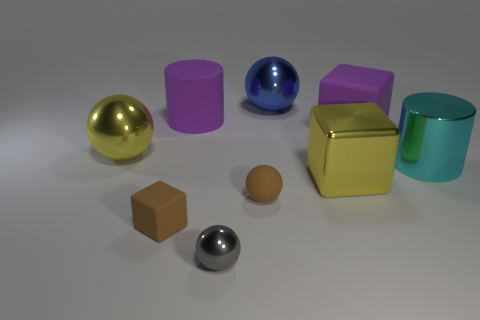Is the number of yellow objects to the right of the yellow metallic sphere greater than the number of cyan metallic cylinders?
Offer a terse response. No. Is the ball on the left side of the small metallic ball made of the same material as the blue object?
Offer a terse response. Yes. There is a cube in front of the tiny brown object right of the brown object that is on the left side of the small gray metallic thing; what is its size?
Make the answer very short. Small. There is a cylinder that is the same material as the blue sphere; what is its size?
Keep it short and to the point. Large. What is the color of the object that is on the right side of the large yellow block and to the left of the cyan thing?
Make the answer very short. Purple. There is a yellow object right of the large yellow metallic sphere; is its shape the same as the brown rubber object left of the big purple cylinder?
Provide a succinct answer. Yes. There is a cylinder behind the big cyan shiny thing; what material is it?
Your response must be concise. Rubber. What size is the rubber block that is the same color as the rubber cylinder?
Offer a terse response. Large. How many things are either large cubes behind the large cyan cylinder or metallic spheres?
Offer a very short reply. 4. Are there the same number of shiny objects that are on the left side of the purple cube and large cylinders?
Give a very brief answer. No. 